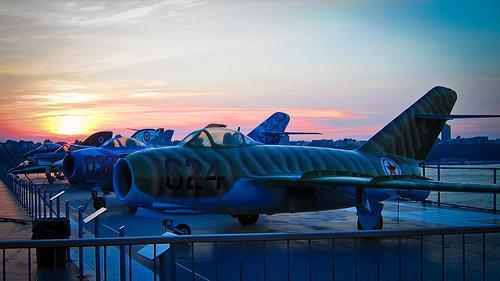How many people can fit in the closest plane?
Give a very brief answer. 1. 